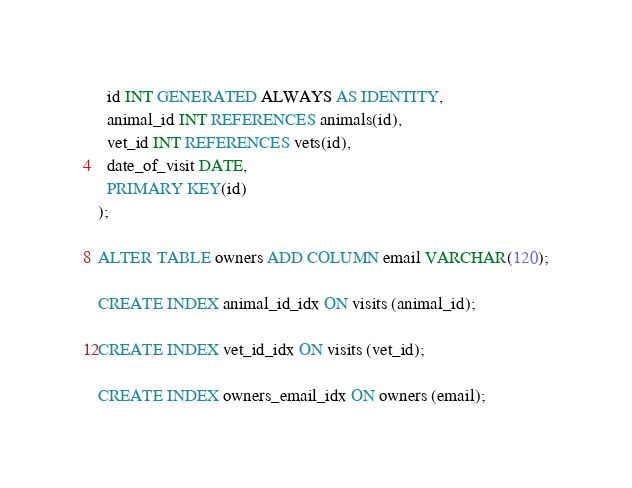<code> <loc_0><loc_0><loc_500><loc_500><_SQL_>  id INT GENERATED ALWAYS AS IDENTITY,
  animal_id INT REFERENCES animals(id),
  vet_id INT REFERENCES vets(id),
  date_of_visit DATE,
  PRIMARY KEY(id)
);

ALTER TABLE owners ADD COLUMN email VARCHAR(120);

CREATE INDEX animal_id_idx ON visits (animal_id);

CREATE INDEX vet_id_idx ON visits (vet_id);

CREATE INDEX owners_email_idx ON owners (email);
</code> 